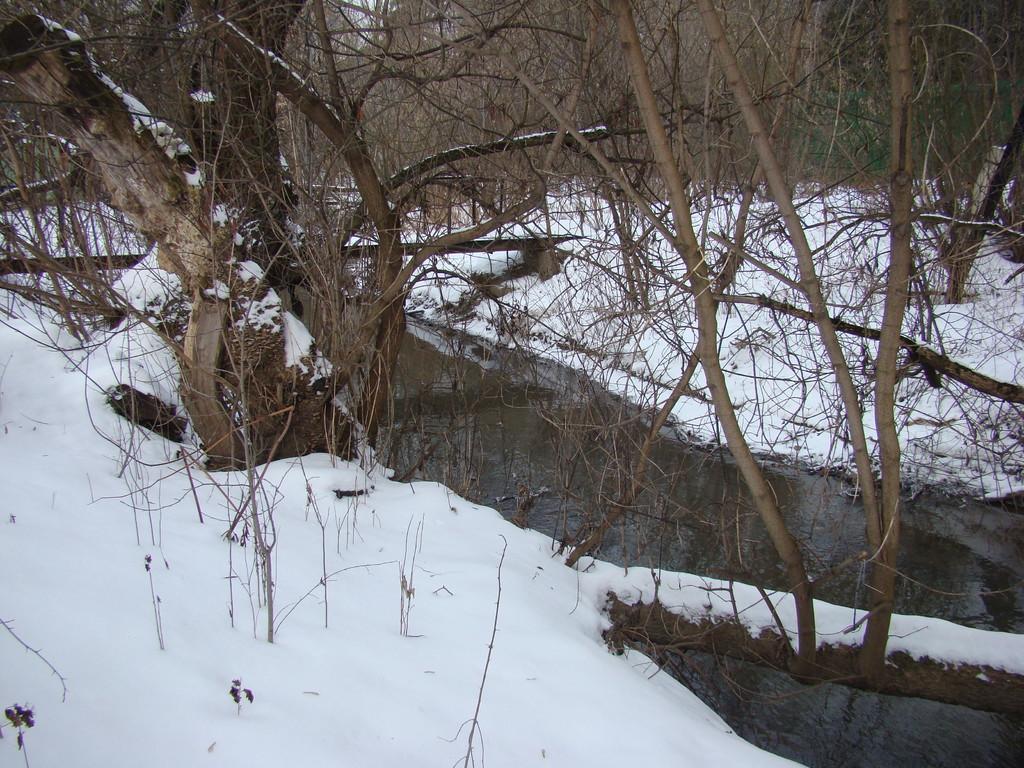How would you summarize this image in a sentence or two? In this image I can see ground full of snow, water and number of trees. 